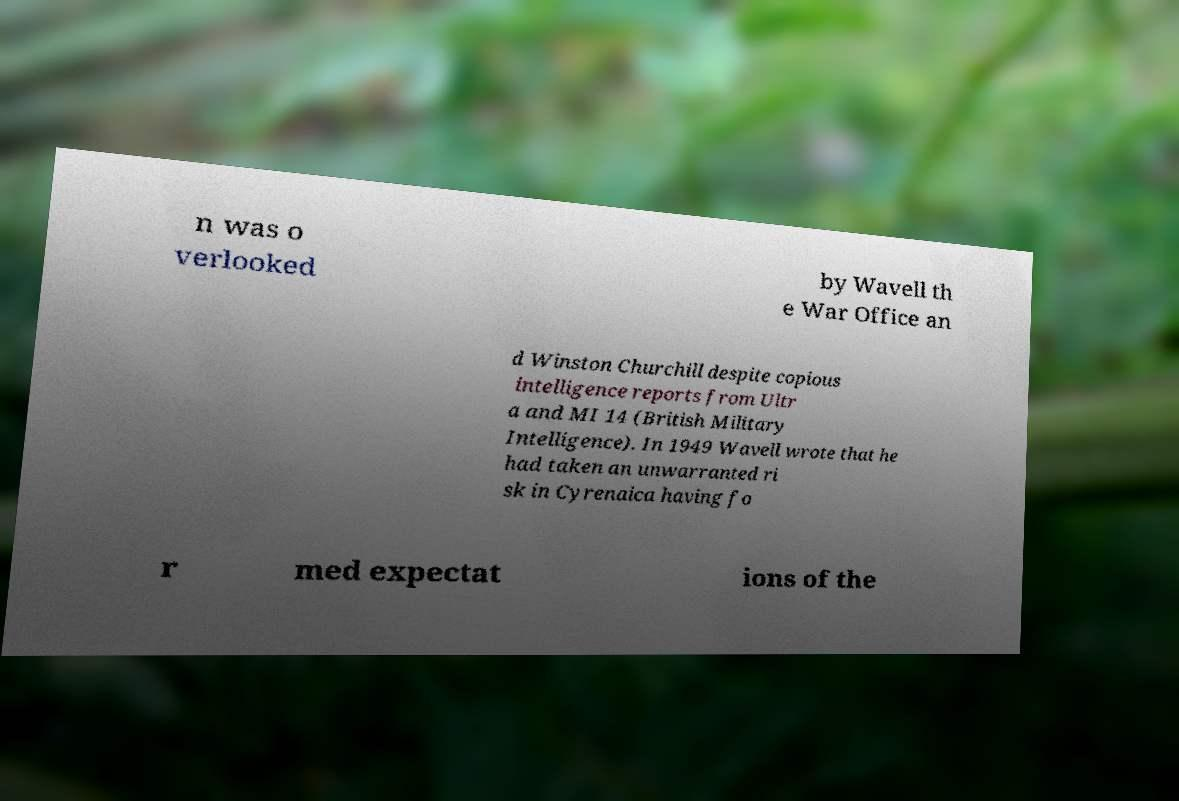Please identify and transcribe the text found in this image. n was o verlooked by Wavell th e War Office an d Winston Churchill despite copious intelligence reports from Ultr a and MI 14 (British Military Intelligence). In 1949 Wavell wrote that he had taken an unwarranted ri sk in Cyrenaica having fo r med expectat ions of the 